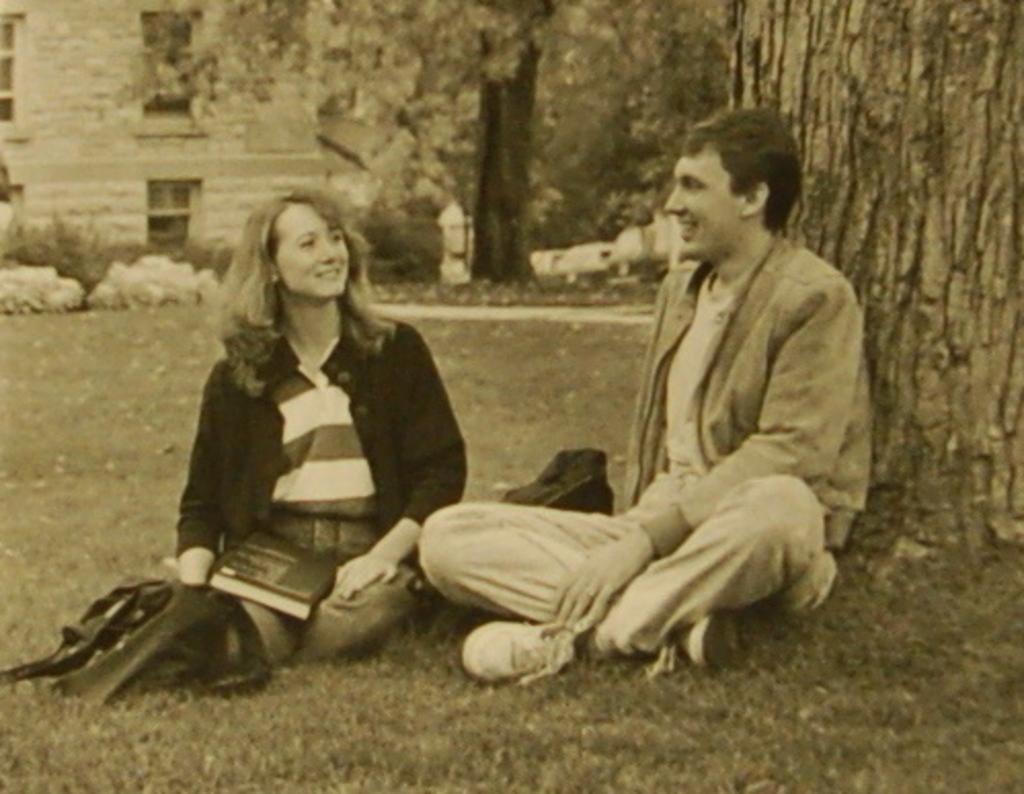Can you describe this image briefly? This image is a black and white image. At the bottom of the image there is a ground with grass on it. In the background there is a building with walls and windows and there are a few trees and plants. In the middle of the image a man and a woman are sitting on the ground and a woman is holding a book in her hand. On the right side of the image there is a tree. 